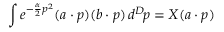Convert formula to latex. <formula><loc_0><loc_0><loc_500><loc_500>\int e ^ { - { \frac { \alpha } { 2 } } p ^ { 2 } } ( a \cdot p ) ( b \cdot p ) \, d ^ { D } \, p = X ( a \cdot p )</formula> 